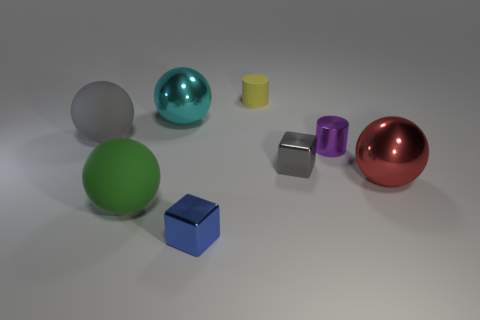Add 2 green matte things. How many objects exist? 10 Subtract all cylinders. How many objects are left? 6 Subtract all purple metallic things. Subtract all large gray objects. How many objects are left? 6 Add 4 cyan balls. How many cyan balls are left? 5 Add 5 large gray spheres. How many large gray spheres exist? 6 Subtract 0 cyan cubes. How many objects are left? 8 